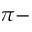Convert formula to latex. <formula><loc_0><loc_0><loc_500><loc_500>\pi -</formula> 